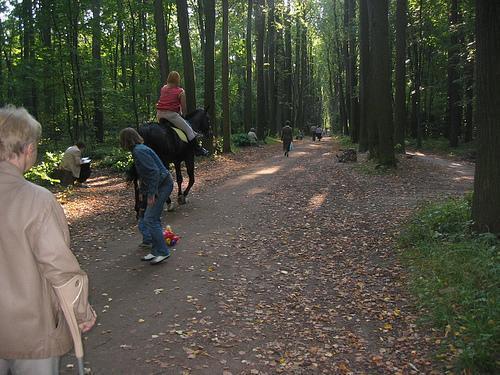What is helping someone walk?
Indicate the correct response by choosing from the four available options to answer the question.
Options: Crutches, branch, walker, cane. Crutches. 